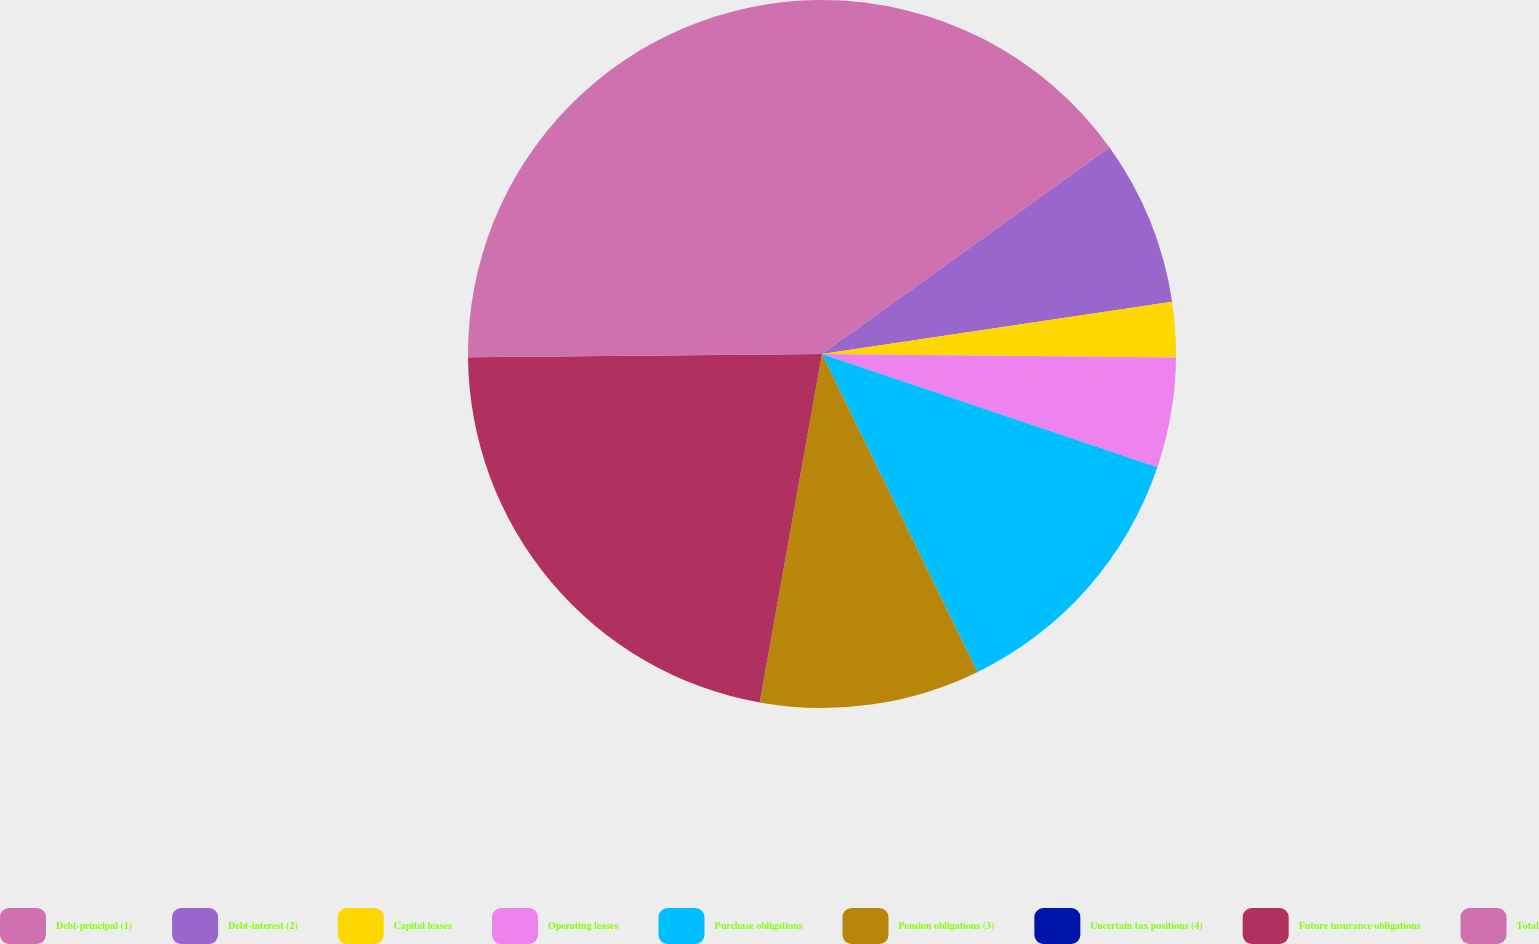<chart> <loc_0><loc_0><loc_500><loc_500><pie_chart><fcel>Debt-principal (1)<fcel>Debt-interest (2)<fcel>Capital leases<fcel>Operating leases<fcel>Purchase obligations<fcel>Pension obligations (3)<fcel>Uncertain tax positions (4)<fcel>Future insurance obligations<fcel>Total<nl><fcel>15.09%<fcel>7.55%<fcel>2.52%<fcel>5.03%<fcel>12.57%<fcel>10.06%<fcel>0.0%<fcel>22.04%<fcel>25.15%<nl></chart> 